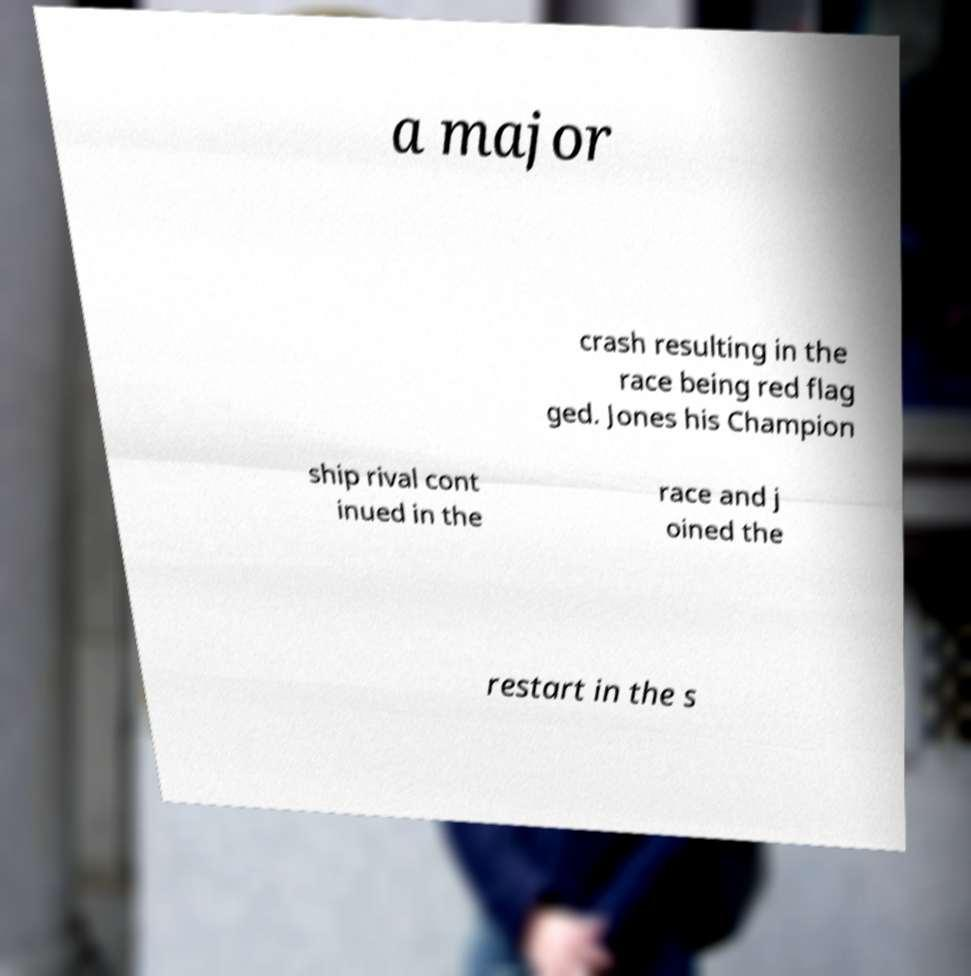Could you extract and type out the text from this image? a major crash resulting in the race being red flag ged. Jones his Champion ship rival cont inued in the race and j oined the restart in the s 